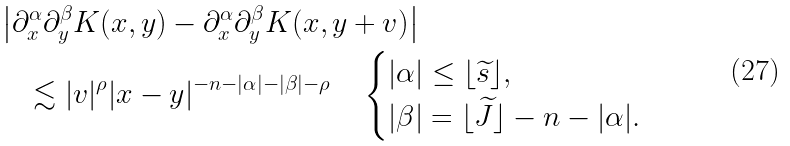<formula> <loc_0><loc_0><loc_500><loc_500>& \left | \partial _ { x } ^ { \alpha } \partial _ { y } ^ { \beta } K ( x , y ) - \partial _ { x } ^ { \alpha } \partial _ { y } ^ { \beta } K ( x , y + v ) \right | \\ & \quad \lesssim | v | ^ { \rho } | x - y | ^ { - n - | \alpha | - | \beta | - \rho } \quad \begin{cases} | \alpha | \leq \lfloor \widetilde { s } \rfloor , \\ | \beta | = \lfloor \widetilde { J } \rfloor - n - | \alpha | . \end{cases}</formula> 